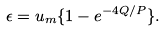Convert formula to latex. <formula><loc_0><loc_0><loc_500><loc_500>\epsilon = u _ { m } \{ 1 - e ^ { - 4 Q / P } \} .</formula> 